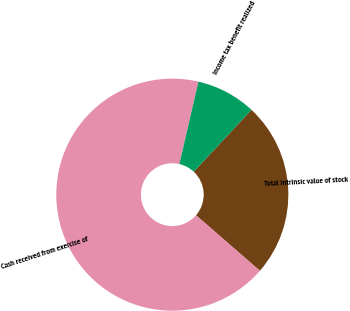Convert chart. <chart><loc_0><loc_0><loc_500><loc_500><pie_chart><fcel>Total intrinsic value of stock<fcel>Cash received from exercise of<fcel>Income tax benefit realized<nl><fcel>24.44%<fcel>67.22%<fcel>8.33%<nl></chart> 